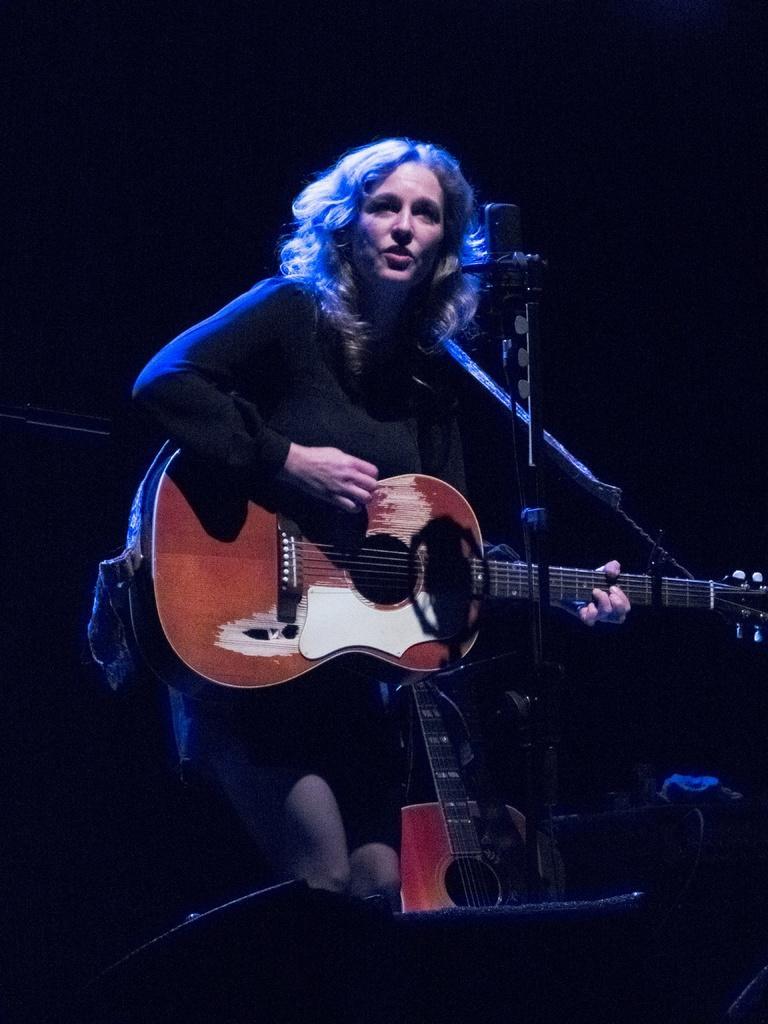Could you give a brief overview of what you see in this image? In this picture i could see a lady holding a guitar in her hands and there is mic in front of her, she is dressed in black in color. 